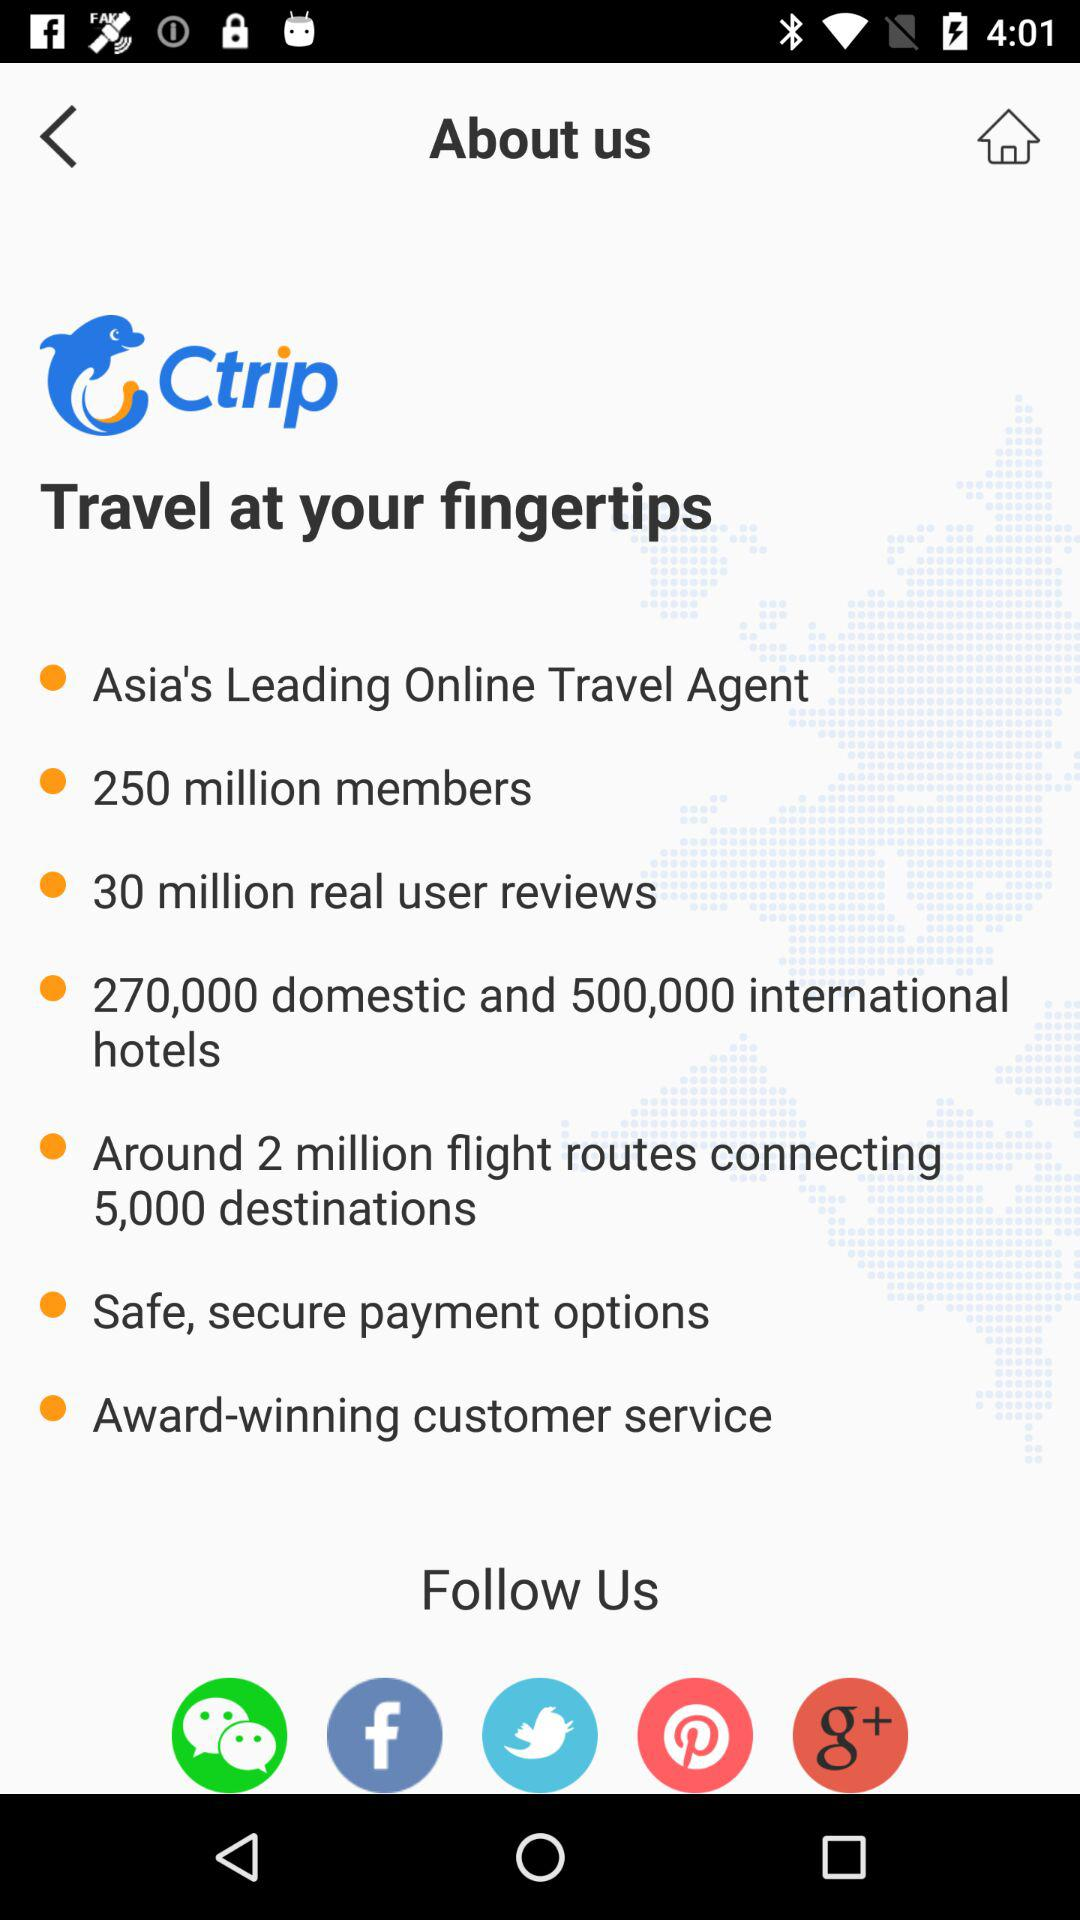How many reviews are received? The reviews are 30 million. 